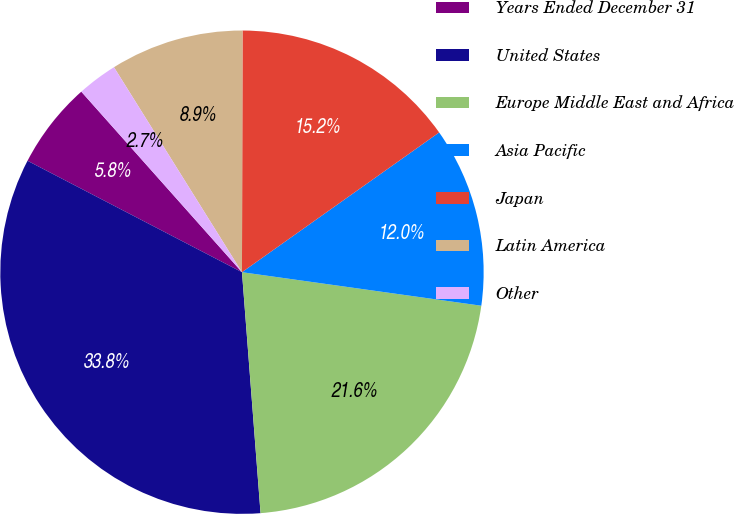Convert chart. <chart><loc_0><loc_0><loc_500><loc_500><pie_chart><fcel>Years Ended December 31<fcel>United States<fcel>Europe Middle East and Africa<fcel>Asia Pacific<fcel>Japan<fcel>Latin America<fcel>Other<nl><fcel>5.8%<fcel>33.85%<fcel>21.56%<fcel>12.03%<fcel>15.15%<fcel>8.92%<fcel>2.69%<nl></chart> 